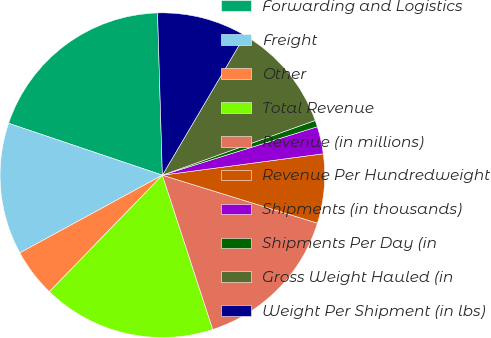Convert chart. <chart><loc_0><loc_0><loc_500><loc_500><pie_chart><fcel>Forwarding and Logistics<fcel>Freight<fcel>Other<fcel>Total Revenue<fcel>Revenue (in millions)<fcel>Revenue Per Hundredweight<fcel>Shipments (in thousands)<fcel>Shipments Per Day (in<fcel>Gross Weight Hauled (in<fcel>Weight Per Shipment (in lbs)<nl><fcel>19.35%<fcel>13.12%<fcel>4.8%<fcel>17.28%<fcel>15.2%<fcel>6.88%<fcel>2.72%<fcel>0.65%<fcel>11.04%<fcel>8.96%<nl></chart> 